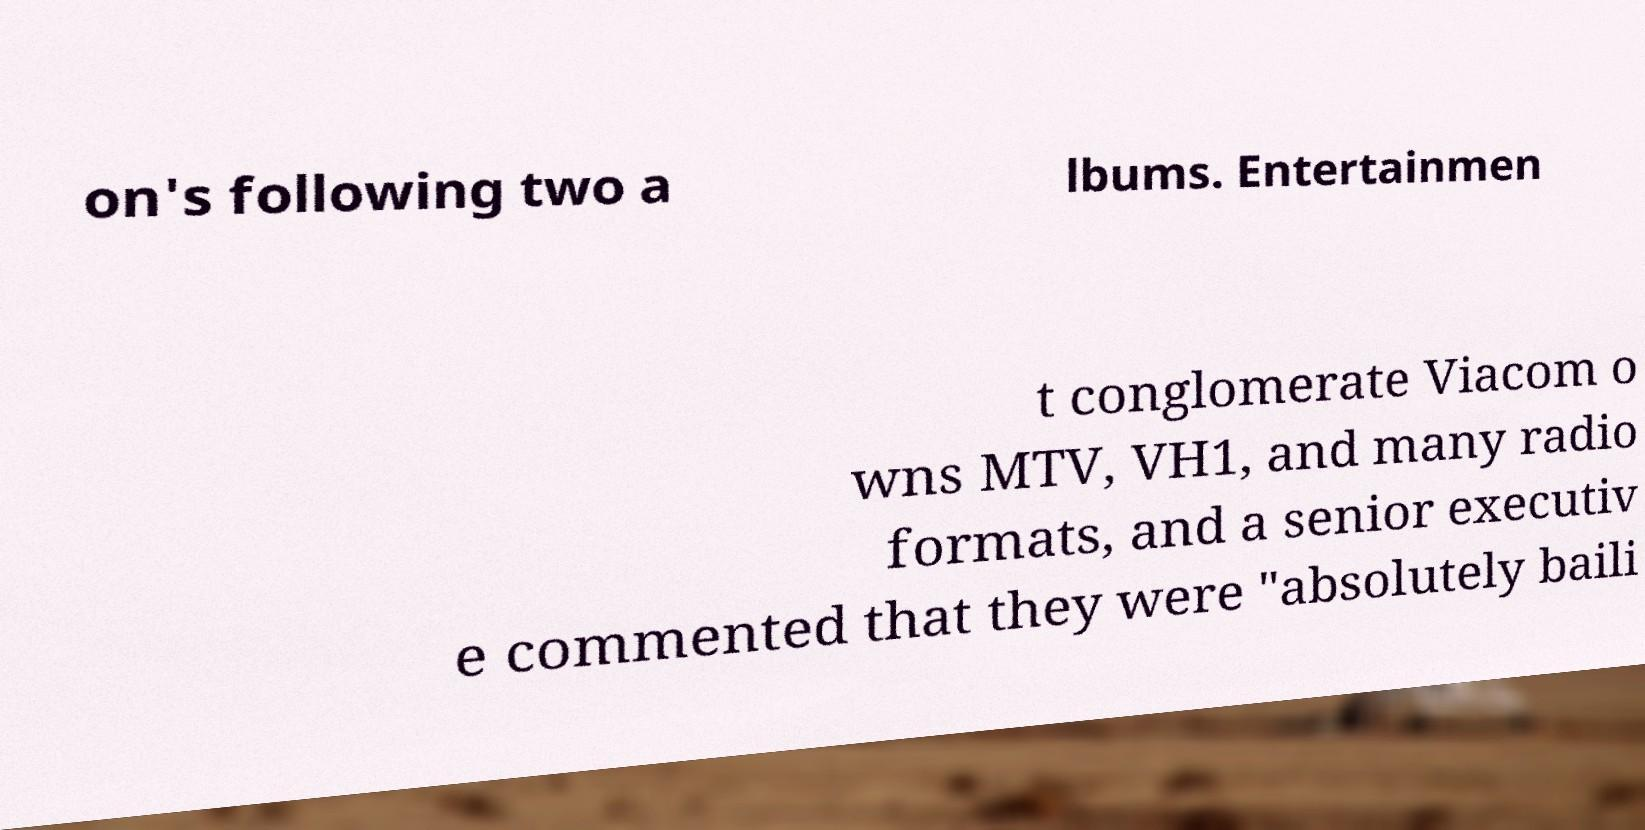Please read and relay the text visible in this image. What does it say? on's following two a lbums. Entertainmen t conglomerate Viacom o wns MTV, VH1, and many radio formats, and a senior executiv e commented that they were "absolutely baili 